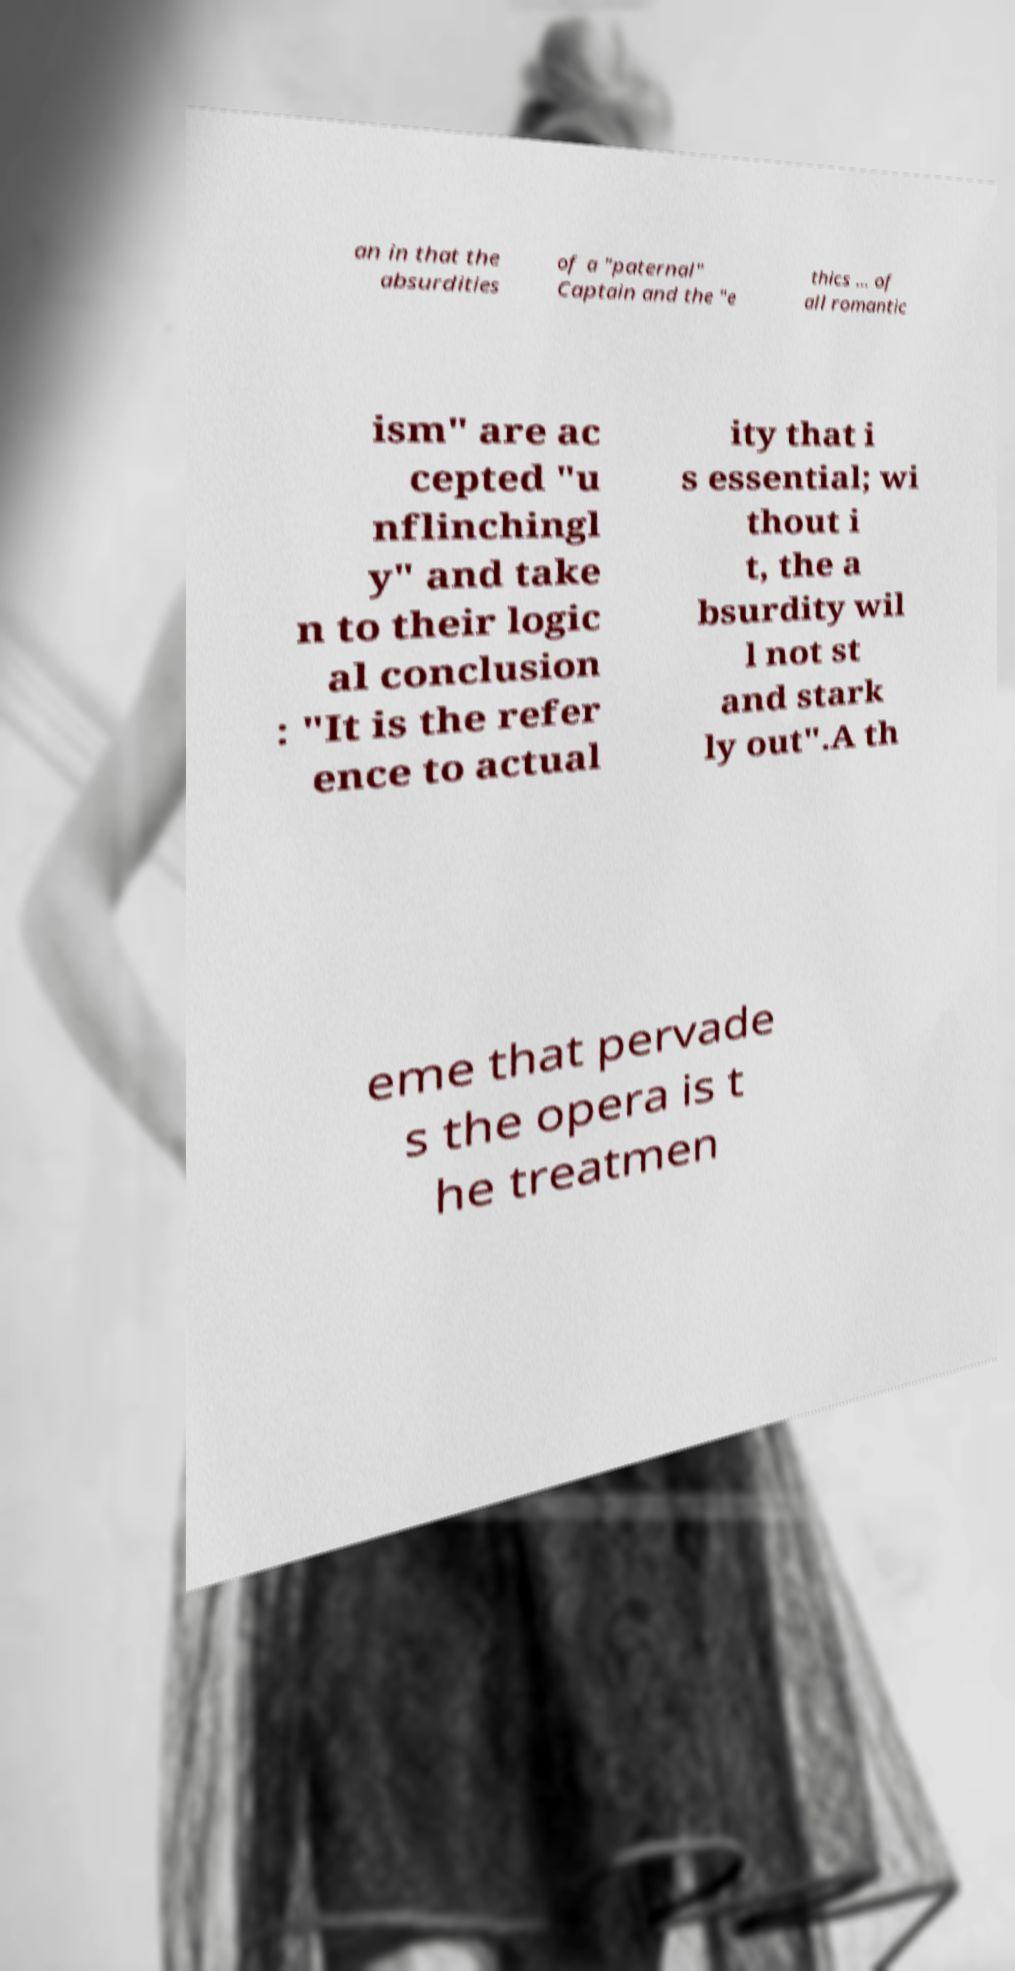For documentation purposes, I need the text within this image transcribed. Could you provide that? an in that the absurdities of a "paternal" Captain and the "e thics ... of all romantic ism" are ac cepted "u nflinchingl y" and take n to their logic al conclusion : "It is the refer ence to actual ity that i s essential; wi thout i t, the a bsurdity wil l not st and stark ly out".A th eme that pervade s the opera is t he treatmen 